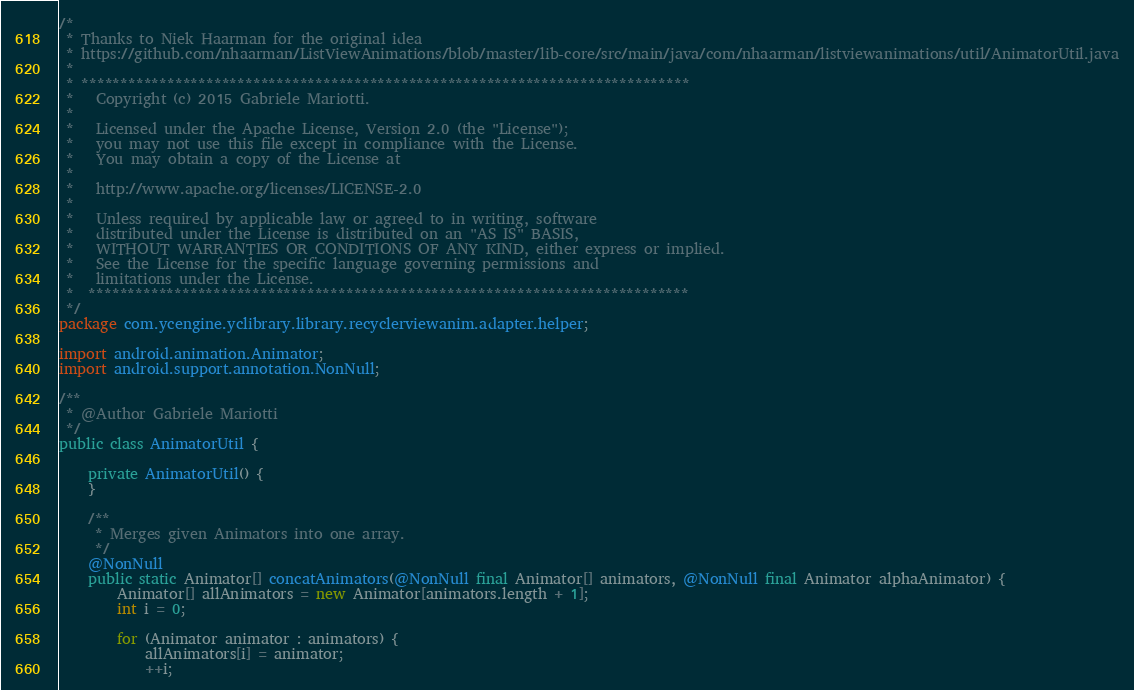<code> <loc_0><loc_0><loc_500><loc_500><_Java_>/*
 * Thanks to Niek Haarman for the original idea
 * https://github.com/nhaarman/ListViewAnimations/blob/master/lib-core/src/main/java/com/nhaarman/listviewanimations/util/AnimatorUtil.java
 *
 * ******************************************************************************
 *   Copyright (c) 2015 Gabriele Mariotti.
 *
 *   Licensed under the Apache License, Version 2.0 (the "License");
 *   you may not use this file except in compliance with the License.
 *   You may obtain a copy of the License at
 *
 *   http://www.apache.org/licenses/LICENSE-2.0
 *
 *   Unless required by applicable law or agreed to in writing, software
 *   distributed under the License is distributed on an "AS IS" BASIS,
 *   WITHOUT WARRANTIES OR CONDITIONS OF ANY KIND, either express or implied.
 *   See the License for the specific language governing permissions and
 *   limitations under the License.
 *  *****************************************************************************
 */
package com.ycengine.yclibrary.library.recyclerviewanim.adapter.helper;

import android.animation.Animator;
import android.support.annotation.NonNull;

/**
 * @Author Gabriele Mariotti
 */
public class AnimatorUtil {

    private AnimatorUtil() {
    }

    /**
     * Merges given Animators into one array.
     */
    @NonNull
    public static Animator[] concatAnimators(@NonNull final Animator[] animators, @NonNull final Animator alphaAnimator) {
        Animator[] allAnimators = new Animator[animators.length + 1];
        int i = 0;

        for (Animator animator : animators) {
            allAnimators[i] = animator;
            ++i;</code> 